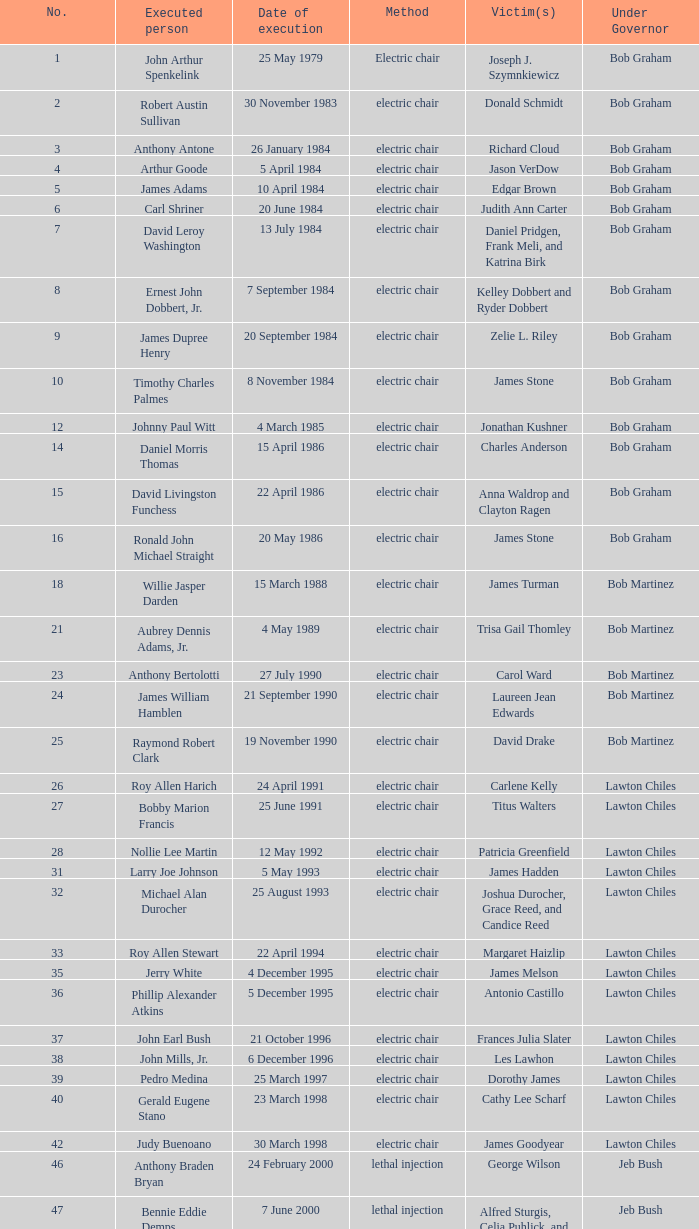What's the name of Linroy Bottoson's victim? Catherine Alexander. 